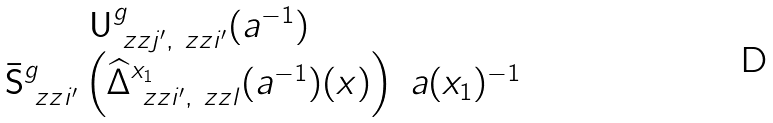Convert formula to latex. <formula><loc_0><loc_0><loc_500><loc_500>\begin{matrix} \mathsf U _ { \ z z j ^ { \prime } , \ z z i ^ { \prime } } ^ { g } ( a ^ { - 1 } ) & \\ \bar { \mathsf S } ^ { g } _ { \ z z i ^ { \prime } } \left ( \widehat { \Delta } ^ { x _ { 1 } } _ { \ z z i ^ { \prime } , \ z z l } ( a ^ { - 1 } ) ( x ) \right ) & a ( x _ { 1 } ) ^ { - 1 } \end{matrix}</formula> 